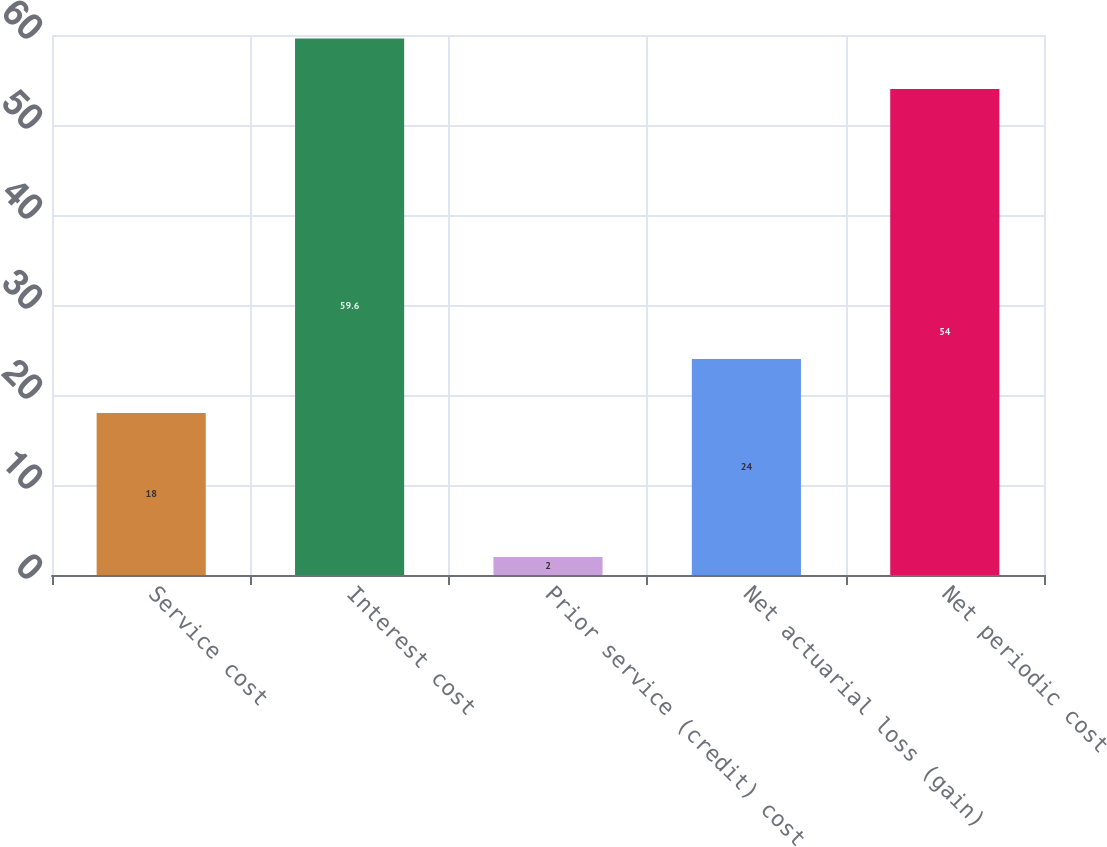Convert chart to OTSL. <chart><loc_0><loc_0><loc_500><loc_500><bar_chart><fcel>Service cost<fcel>Interest cost<fcel>Prior service (credit) cost<fcel>Net actuarial loss (gain)<fcel>Net periodic cost<nl><fcel>18<fcel>59.6<fcel>2<fcel>24<fcel>54<nl></chart> 